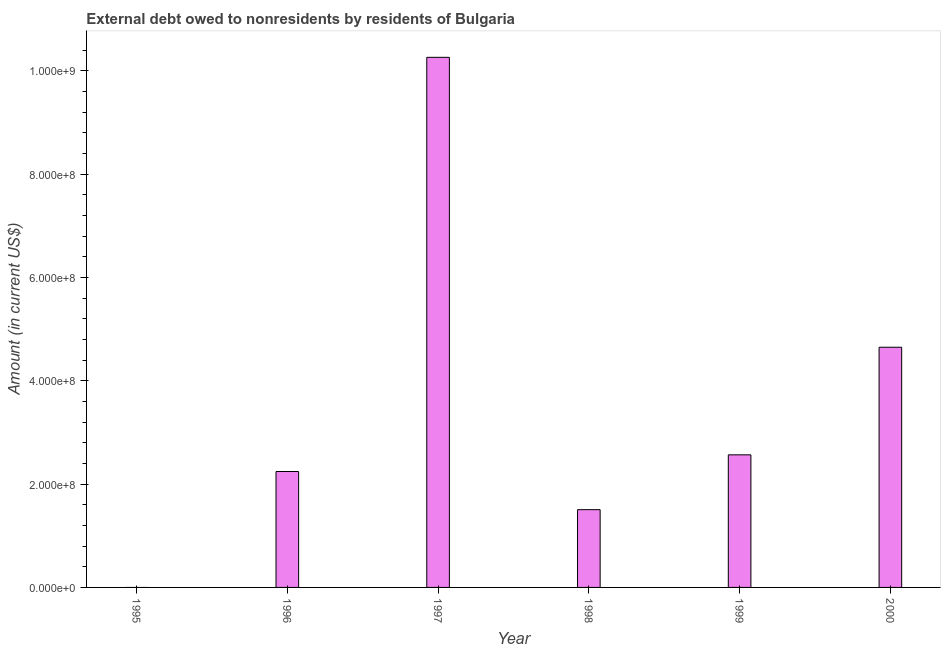Does the graph contain any zero values?
Your answer should be compact. Yes. Does the graph contain grids?
Make the answer very short. No. What is the title of the graph?
Your response must be concise. External debt owed to nonresidents by residents of Bulgaria. What is the label or title of the X-axis?
Make the answer very short. Year. What is the label or title of the Y-axis?
Keep it short and to the point. Amount (in current US$). What is the debt in 1998?
Your answer should be very brief. 1.51e+08. Across all years, what is the maximum debt?
Make the answer very short. 1.03e+09. What is the sum of the debt?
Offer a terse response. 2.12e+09. What is the difference between the debt in 1998 and 1999?
Your response must be concise. -1.06e+08. What is the average debt per year?
Offer a terse response. 3.54e+08. What is the median debt?
Provide a succinct answer. 2.41e+08. In how many years, is the debt greater than 880000000 US$?
Provide a succinct answer. 1. What is the ratio of the debt in 1999 to that in 2000?
Your response must be concise. 0.55. Is the debt in 1996 less than that in 1999?
Your answer should be very brief. Yes. What is the difference between the highest and the second highest debt?
Offer a very short reply. 5.61e+08. Is the sum of the debt in 1996 and 1999 greater than the maximum debt across all years?
Give a very brief answer. No. What is the difference between the highest and the lowest debt?
Give a very brief answer. 1.03e+09. In how many years, is the debt greater than the average debt taken over all years?
Provide a short and direct response. 2. How many years are there in the graph?
Your answer should be compact. 6. What is the difference between two consecutive major ticks on the Y-axis?
Offer a very short reply. 2.00e+08. What is the Amount (in current US$) of 1996?
Provide a short and direct response. 2.24e+08. What is the Amount (in current US$) in 1997?
Your answer should be compact. 1.03e+09. What is the Amount (in current US$) in 1998?
Your answer should be very brief. 1.51e+08. What is the Amount (in current US$) of 1999?
Your answer should be very brief. 2.57e+08. What is the Amount (in current US$) of 2000?
Make the answer very short. 4.65e+08. What is the difference between the Amount (in current US$) in 1996 and 1997?
Make the answer very short. -8.02e+08. What is the difference between the Amount (in current US$) in 1996 and 1998?
Provide a succinct answer. 7.39e+07. What is the difference between the Amount (in current US$) in 1996 and 1999?
Your answer should be compact. -3.23e+07. What is the difference between the Amount (in current US$) in 1996 and 2000?
Keep it short and to the point. -2.41e+08. What is the difference between the Amount (in current US$) in 1997 and 1998?
Provide a succinct answer. 8.76e+08. What is the difference between the Amount (in current US$) in 1997 and 1999?
Offer a terse response. 7.70e+08. What is the difference between the Amount (in current US$) in 1997 and 2000?
Ensure brevity in your answer.  5.61e+08. What is the difference between the Amount (in current US$) in 1998 and 1999?
Provide a succinct answer. -1.06e+08. What is the difference between the Amount (in current US$) in 1998 and 2000?
Your answer should be compact. -3.14e+08. What is the difference between the Amount (in current US$) in 1999 and 2000?
Your response must be concise. -2.08e+08. What is the ratio of the Amount (in current US$) in 1996 to that in 1997?
Your answer should be very brief. 0.22. What is the ratio of the Amount (in current US$) in 1996 to that in 1998?
Offer a terse response. 1.49. What is the ratio of the Amount (in current US$) in 1996 to that in 1999?
Offer a terse response. 0.87. What is the ratio of the Amount (in current US$) in 1996 to that in 2000?
Give a very brief answer. 0.48. What is the ratio of the Amount (in current US$) in 1997 to that in 1998?
Provide a short and direct response. 6.82. What is the ratio of the Amount (in current US$) in 1997 to that in 1999?
Your response must be concise. 4. What is the ratio of the Amount (in current US$) in 1997 to that in 2000?
Keep it short and to the point. 2.21. What is the ratio of the Amount (in current US$) in 1998 to that in 1999?
Your answer should be compact. 0.59. What is the ratio of the Amount (in current US$) in 1998 to that in 2000?
Provide a short and direct response. 0.32. What is the ratio of the Amount (in current US$) in 1999 to that in 2000?
Your response must be concise. 0.55. 